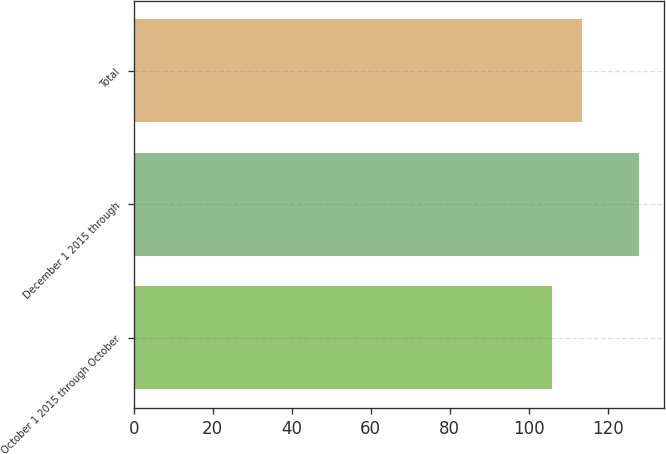Convert chart. <chart><loc_0><loc_0><loc_500><loc_500><bar_chart><fcel>October 1 2015 through October<fcel>December 1 2015 through<fcel>Total<nl><fcel>105.81<fcel>127.93<fcel>113.5<nl></chart> 